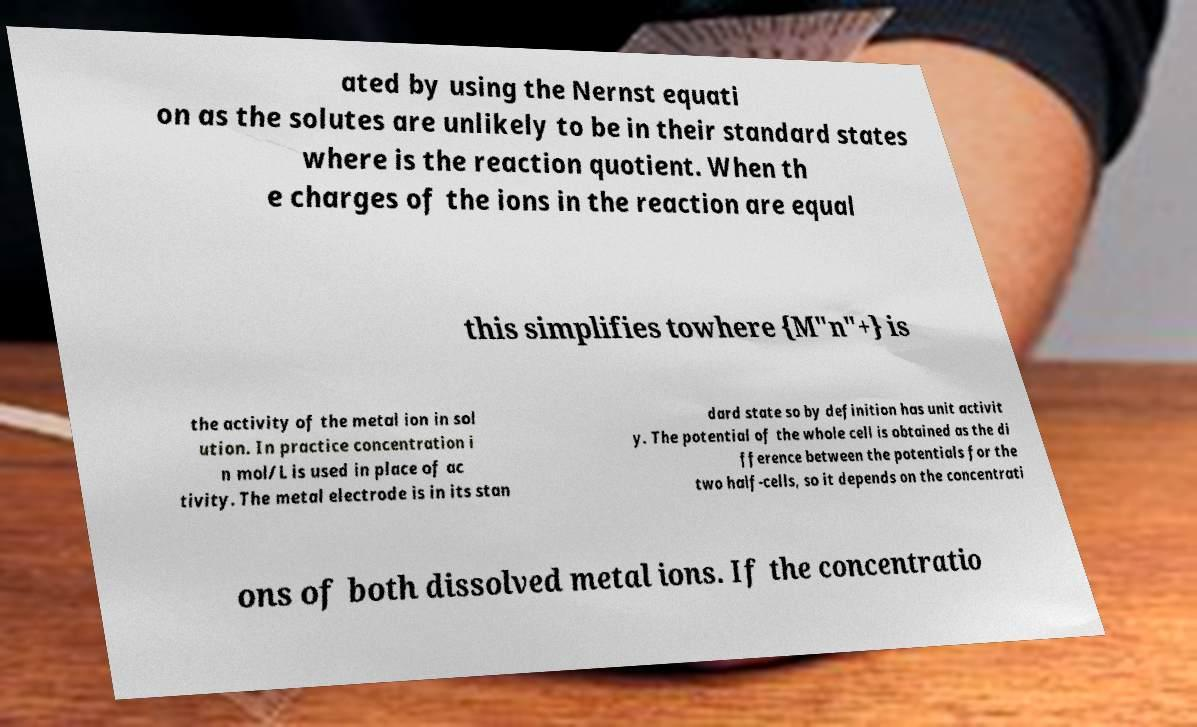Please read and relay the text visible in this image. What does it say? ated by using the Nernst equati on as the solutes are unlikely to be in their standard states where is the reaction quotient. When th e charges of the ions in the reaction are equal this simplifies towhere {M"n"+} is the activity of the metal ion in sol ution. In practice concentration i n mol/L is used in place of ac tivity. The metal electrode is in its stan dard state so by definition has unit activit y. The potential of the whole cell is obtained as the di fference between the potentials for the two half-cells, so it depends on the concentrati ons of both dissolved metal ions. If the concentratio 